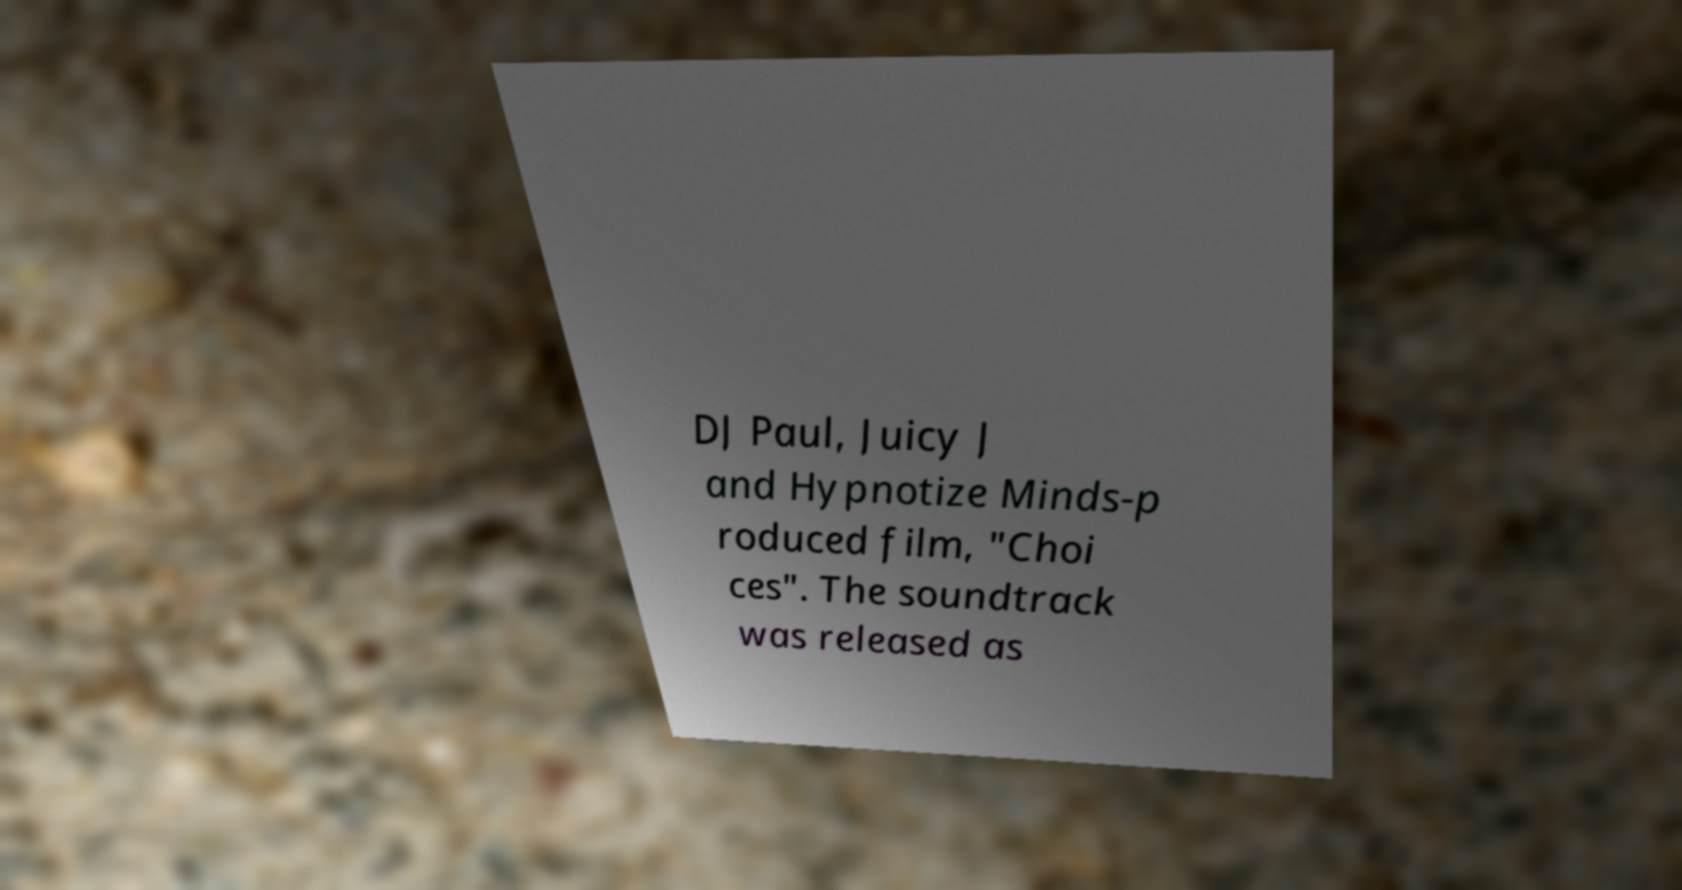For documentation purposes, I need the text within this image transcribed. Could you provide that? DJ Paul, Juicy J and Hypnotize Minds-p roduced film, "Choi ces". The soundtrack was released as 